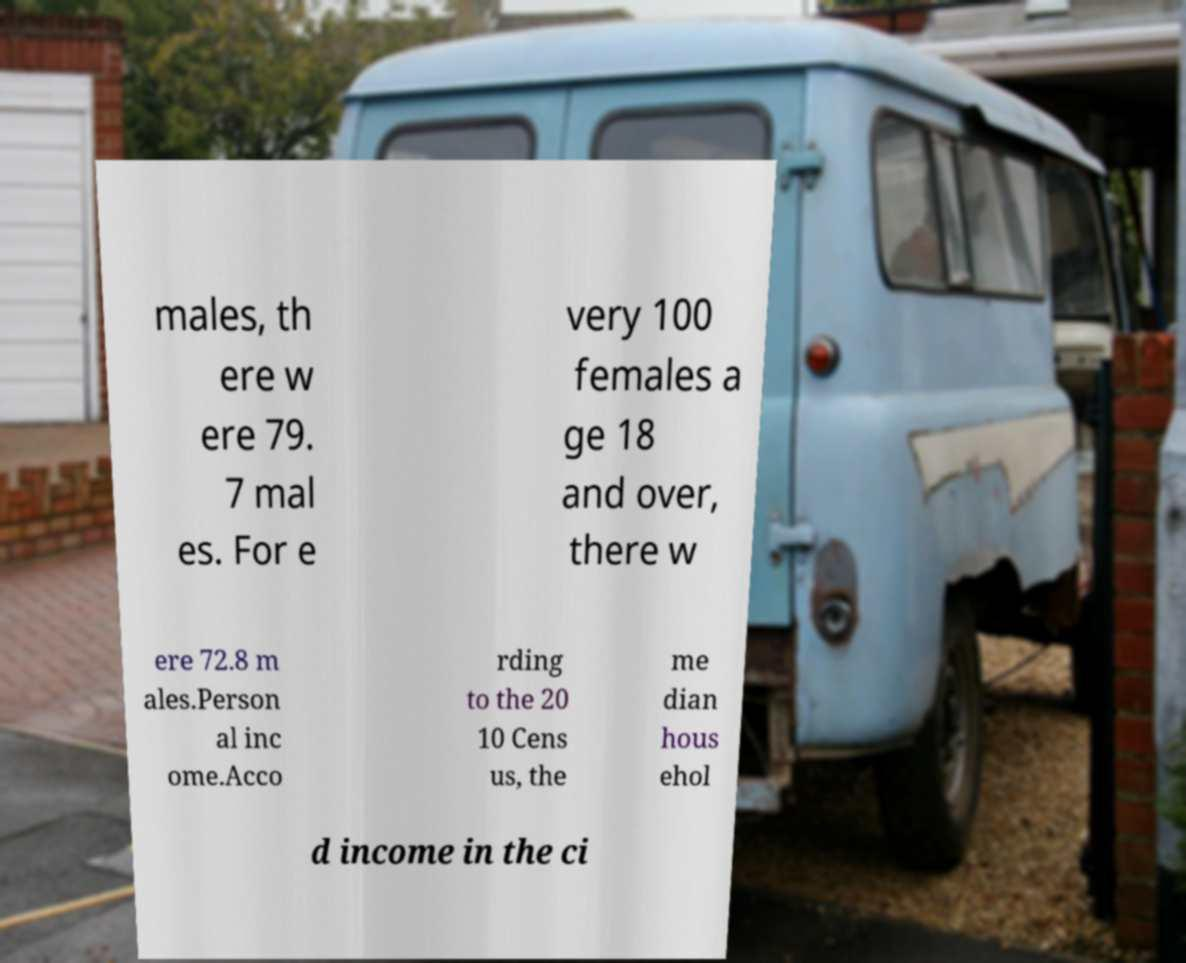Can you read and provide the text displayed in the image?This photo seems to have some interesting text. Can you extract and type it out for me? males, th ere w ere 79. 7 mal es. For e very 100 females a ge 18 and over, there w ere 72.8 m ales.Person al inc ome.Acco rding to the 20 10 Cens us, the me dian hous ehol d income in the ci 